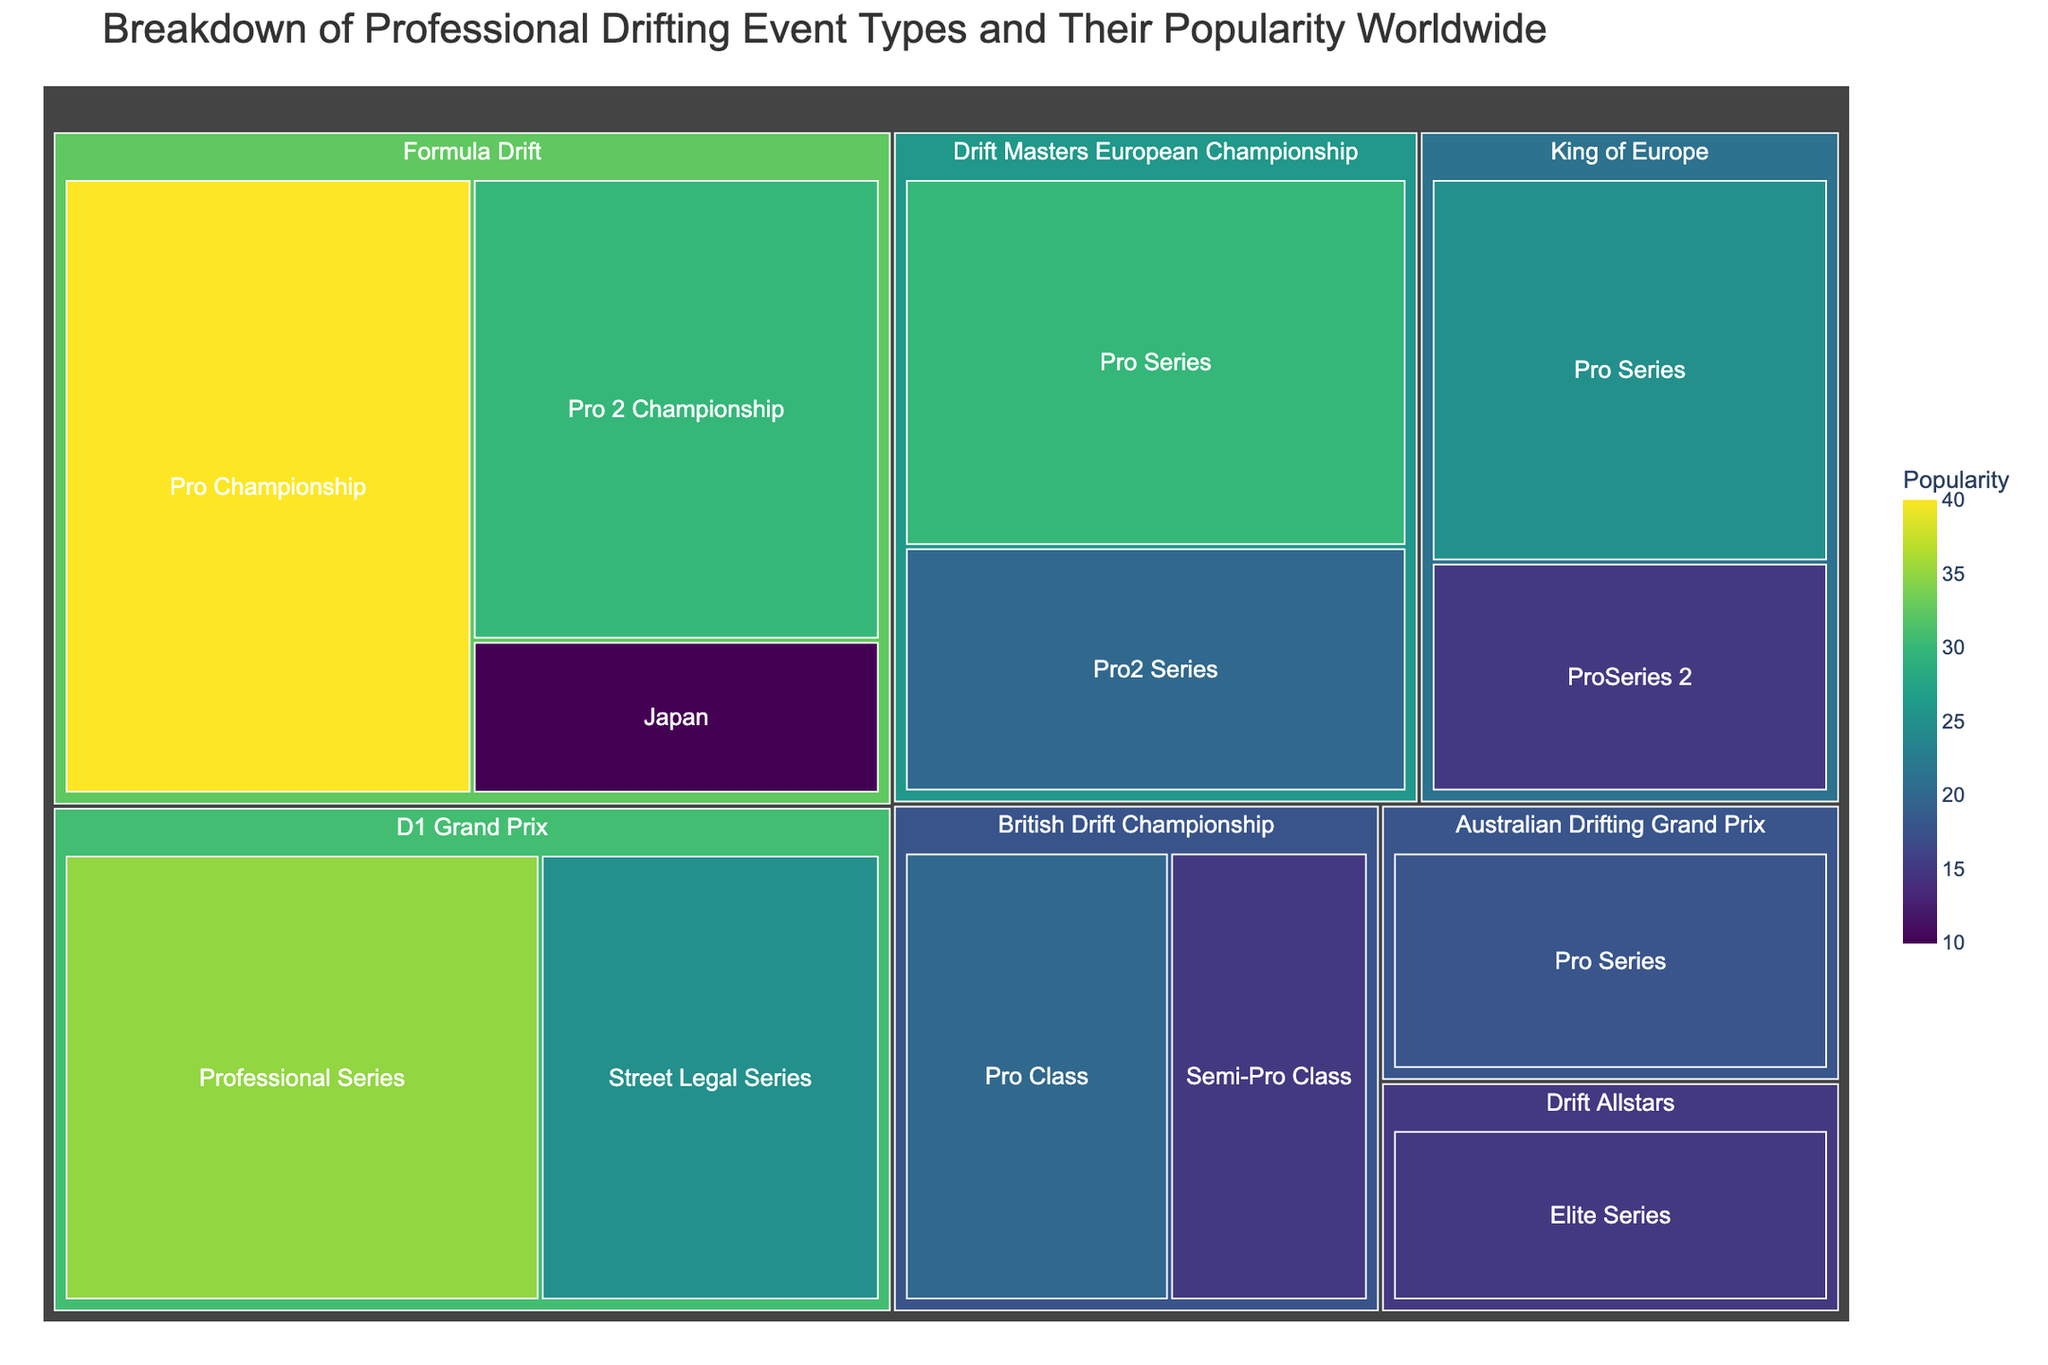What's the most popular sub-event overall? By observing the figure, the sub-event with the largest area and highest color intensity represents the highest popularity. "Pro Championship" under "Formula Drift" has the largest area and darkest color.
Answer: Pro Championship Which event type has the highest overall popularity? The aggregated area of all sub-events under each event type signals overall popularity. "Formula Drift" occupies the largest combined area among all the event types.
Answer: Formula Drift Which event type has the least overall popularity? By comparing the aggregated areas of all sub-events under each event type, "Drift Allstars" has the smallest combined area.
Answer: Drift Allstars What is the popularity difference between "Formula Drift" and "D1 Grand Prix"? Sum up the popularity of all sub-events under each event type. Formula Drift: 40+30+10=80, D1 Grand Prix: 35+25=60. Difference is 80-60.
Answer: 20 What is the combined popularity of all sub-events in the "Drift Masters European Championship"? Sum up the popularity of "Pro Series" and "Pro2 Series" under "Drift Masters European Championship". 30 + 20 = 50.
Answer: 50 Which sub-event is the least popular in the "Formula Drift" category? Look for the sub-event under "Formula Drift" with the smallest area and least intense color. "Japan" has the smallest area.
Answer: Japan Compare the popularity of the "Pro Series" in "King of Europe" and "Australian Drifting Grand Prix". Which one is more popular? Identify the area sizes of these sub-events. "Pro Series" in "King of Europe" has a popularity of 25, while "Pro Series" in "Australian Drifting Grand Prix" has 18.
Answer: King of Europe What is the total popularity of all sub-events with "Pro" in their name? Sum up the popularity values of all sub-events containing "Pro" in their names: Pro Championship (40), Pro 2 Championship (30), Pro Series (30, 25, 18), Pro2 Series (20), Pro Class (20). 40 + 30 + 30 + 25 + 18 + 20 + 20 = 183.
Answer: 183 What's the smallest popularity value shown for any sub-event? Scan the figure for the smallest area and lightest color to find the least popular sub-event, which is "Japan" under "Formula Drift" with a popularity of 10.
Answer: 10 Among "British Drift Championship" sub-events, which one is more popular? Comparing the areas and colors of the sub-events under "British Drift Championship", "Pro Class" has a larger area than "Semi-Pro Class".
Answer: Pro Class 